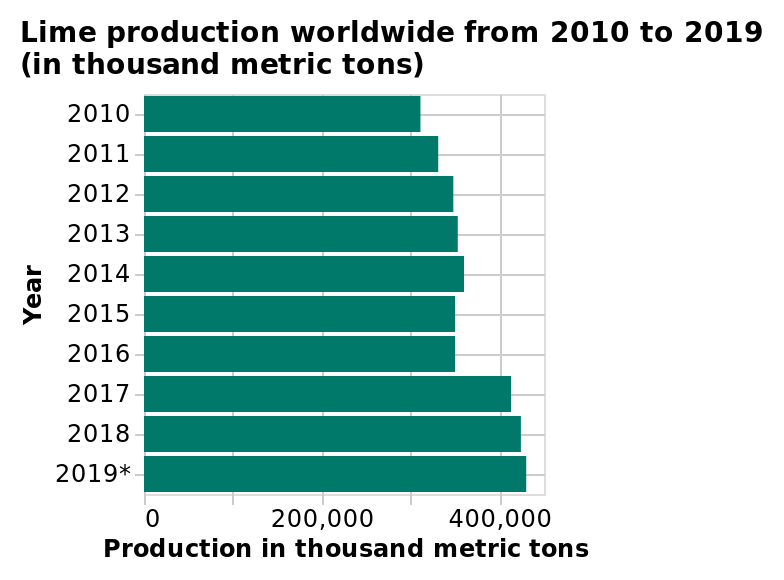<image>
please enumerates aspects of the construction of the chart This is a bar chart titled Lime production worldwide from 2010 to 2019 (in thousand metric tons). The y-axis measures Year while the x-axis plots Production in thousand metric tons. What is the range of lime production shown on the x-axis? The range of lime production shown on the x-axis is from 0 to 2019 thousand metric tons. 